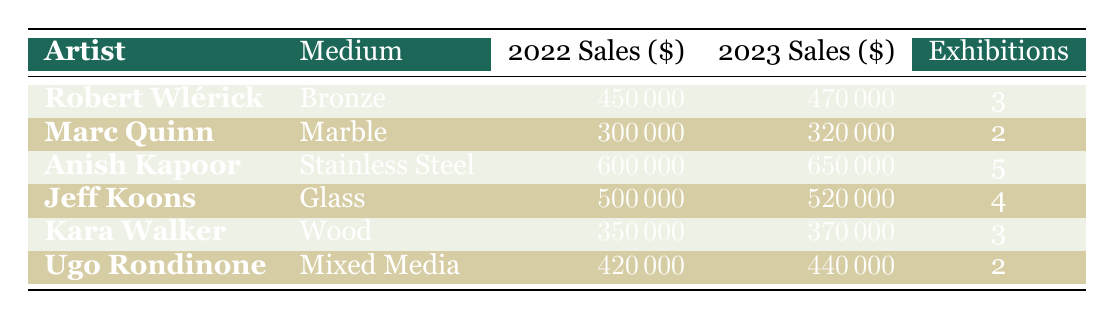What were the sales for Robert Wlérick in 2022? The table shows that Robert Wlérick had sales of 450,000 in the year 2022.
Answer: 450000 Which artist had the highest sales in 2023? By comparing the sales figures for 2023, Anish Kapoor had the highest sales of 650,000.
Answer: Anish Kapoor What is the difference in sales for Jeff Koons between 2022 and 2023? The sales for Jeff Koons in 2022 were 500,000, and in 2023 they were 520,000. The difference is 520,000 - 500,000 = 20,000.
Answer: 20000 Did Ugo Rondinone have more exhibitions than Marc Quinn? Ugo Rondinone had 2 exhibitions, while Marc Quinn also had 2 exhibitions. This means they had the same number of exhibitions.
Answer: No What is the average sales amount for all artists listed in 2022? To find the average sales for 2022, add the sales figures: 450,000 + 300,000 + 600,000 + 500,000 + 350,000 + 420,000 = 2,620,000. Dividing by the number of artists (6), gives an average of 2,620,000 / 6 = 436,666.67.
Answer: 436666.67 Which medium had the lowest sales in 2023? Reviewing the sales figures for 2023, Marc Quinn's Marble had the lowest sales of 320,000 compared to other mediums.
Answer: Marble How much did sales increase for Anish Kapoor from 2022 to 2023? Anish Kapoor had sales of 600,000 in 2022 and increased to 650,000 in 2023. The increase is calculated as 650,000 - 600,000 = 50,000.
Answer: 50000 Was the sales increase for Robert Wlérick in 2023 compared to 2022 greater than the increase for Jeff Koons? Robert Wlérick's sales increased by 20,000, while Jeff Koons' sales increased by 20,000 as well. Since both increases are equal, the answer is no, Robert Wlérick's increase was not greater than Jeff Koons'.
Answer: No 